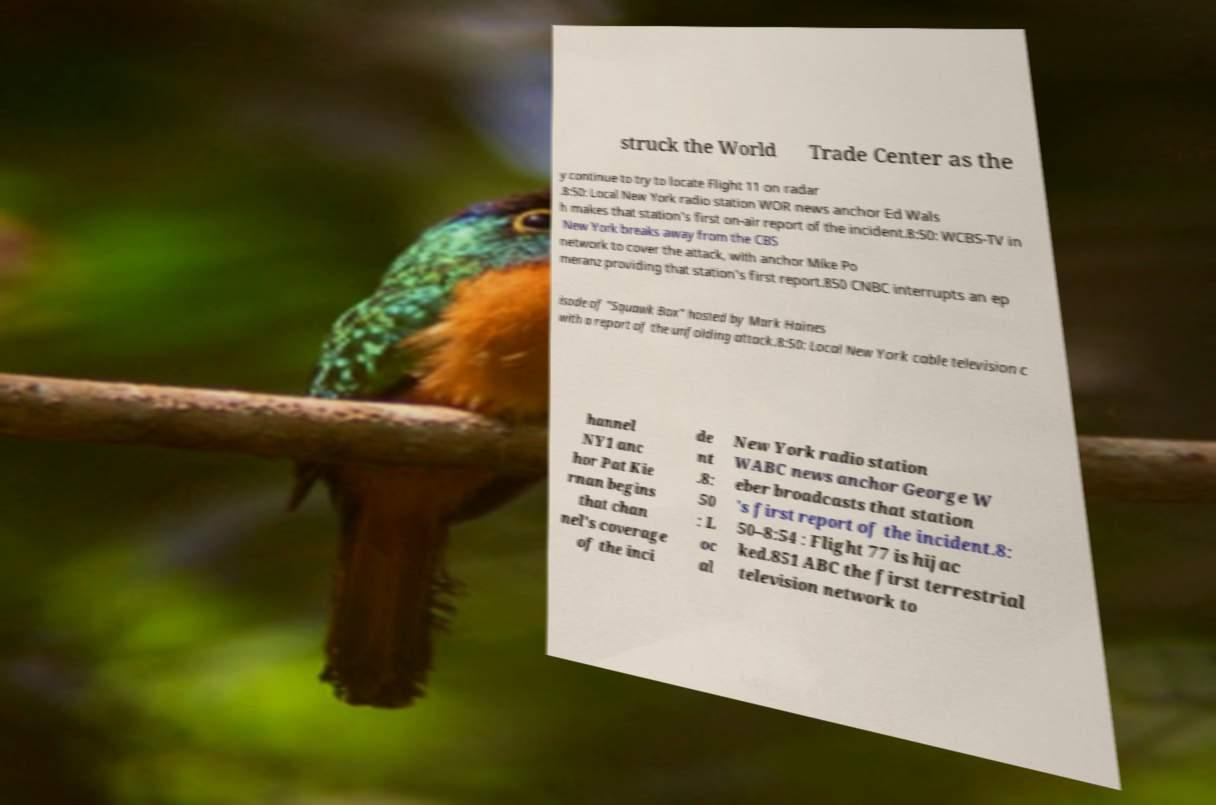Could you extract and type out the text from this image? struck the World Trade Center as the y continue to try to locate Flight 11 on radar .8:50: Local New York radio station WOR news anchor Ed Wals h makes that station's first on-air report of the incident.8:50: WCBS-TV in New York breaks away from the CBS network to cover the attack, with anchor Mike Po meranz providing that station's first report.850 CNBC interrupts an ep isode of "Squawk Box" hosted by Mark Haines with a report of the unfolding attack.8:50: Local New York cable television c hannel NY1 anc hor Pat Kie rnan begins that chan nel's coverage of the inci de nt .8: 50 : L oc al New York radio station WABC news anchor George W eber broadcasts that station 's first report of the incident.8: 50–8:54 : Flight 77 is hijac ked.851 ABC the first terrestrial television network to 